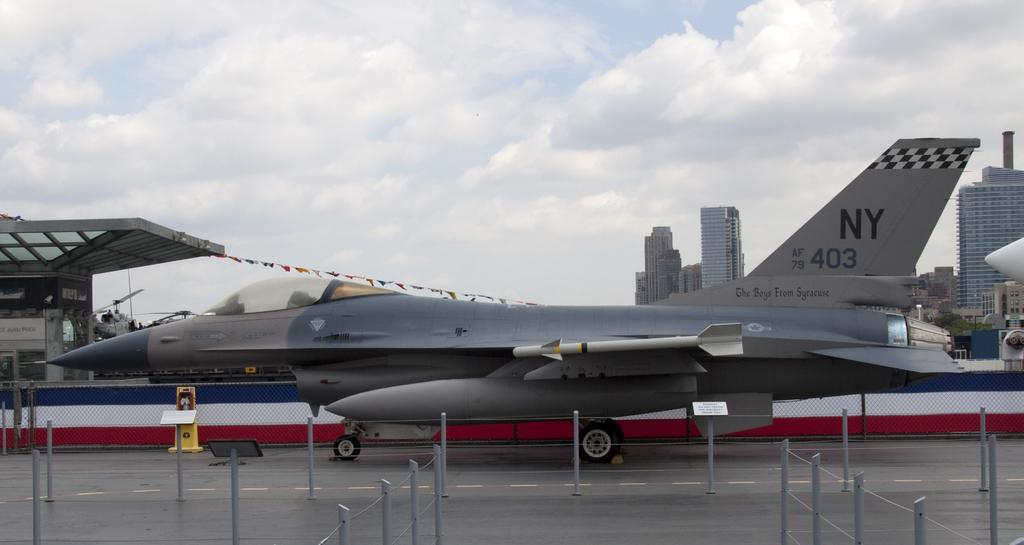Provide a one-sentence caption for the provided image. A fighter jet with the letters NY on it's tail is sitting on a runway in a city. 